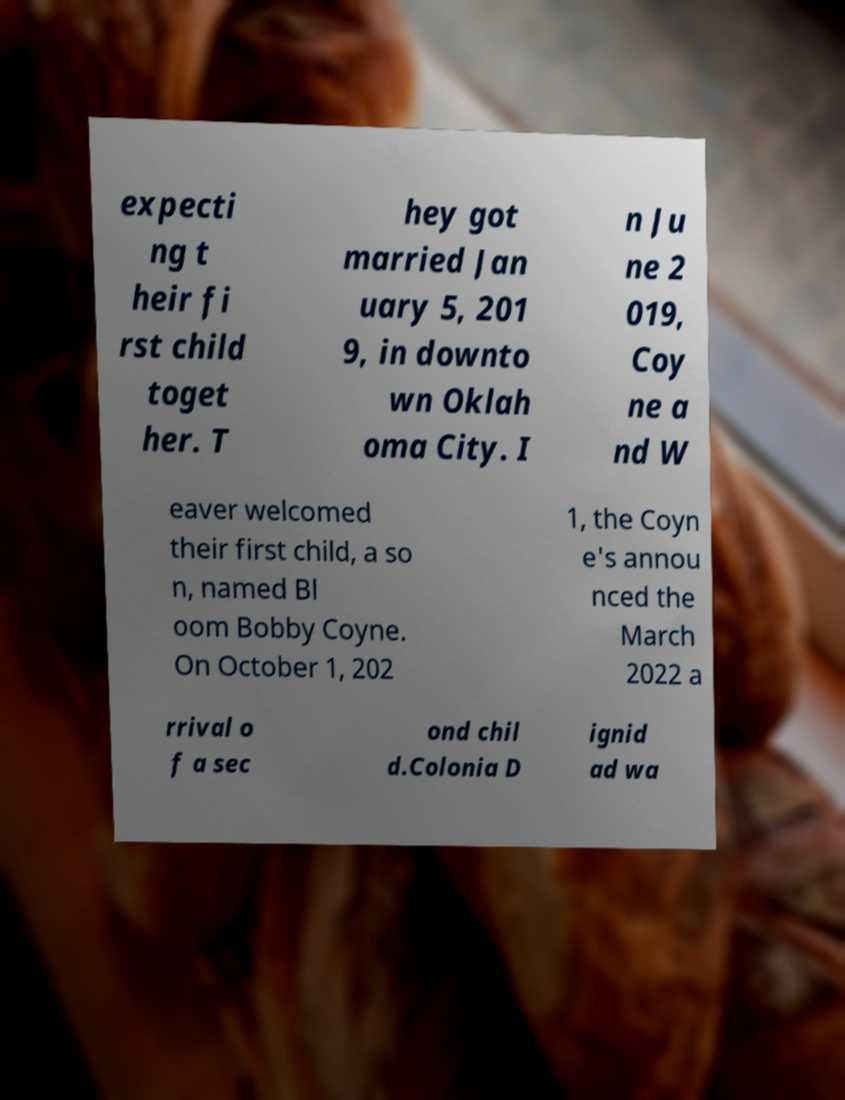Please identify and transcribe the text found in this image. expecti ng t heir fi rst child toget her. T hey got married Jan uary 5, 201 9, in downto wn Oklah oma City. I n Ju ne 2 019, Coy ne a nd W eaver welcomed their first child, a so n, named Bl oom Bobby Coyne. On October 1, 202 1, the Coyn e's annou nced the March 2022 a rrival o f a sec ond chil d.Colonia D ignid ad wa 